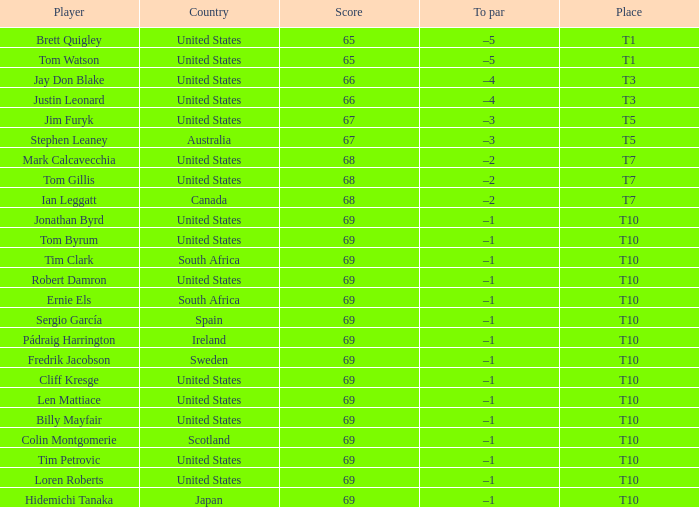What is Tom Gillis' score? 68.0. 